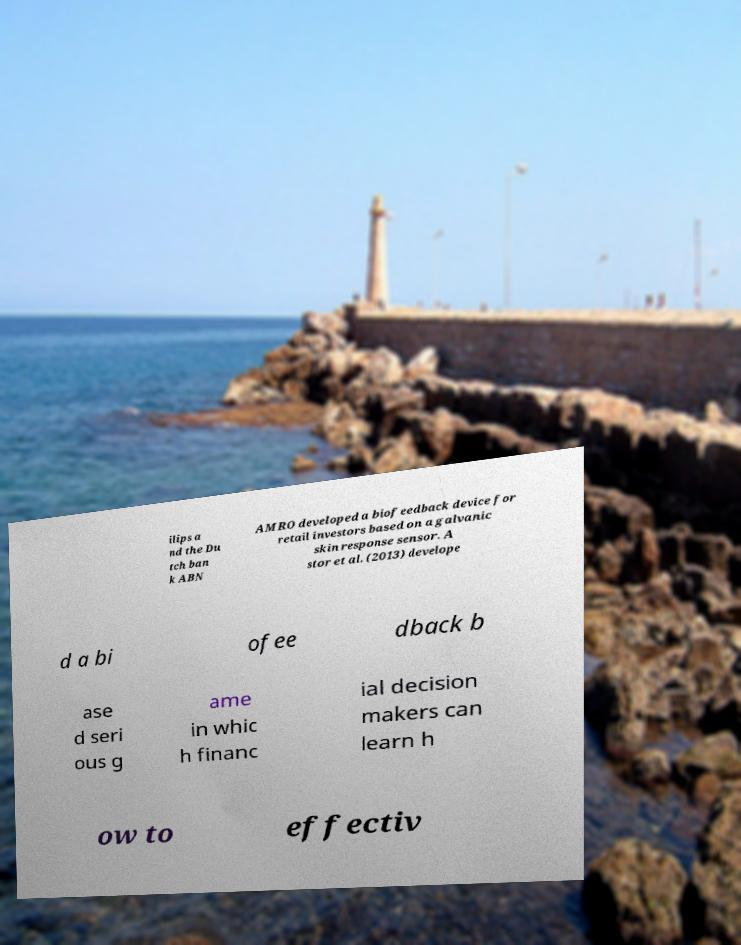There's text embedded in this image that I need extracted. Can you transcribe it verbatim? ilips a nd the Du tch ban k ABN AMRO developed a biofeedback device for retail investors based on a galvanic skin response sensor. A stor et al. (2013) develope d a bi ofee dback b ase d seri ous g ame in whic h financ ial decision makers can learn h ow to effectiv 